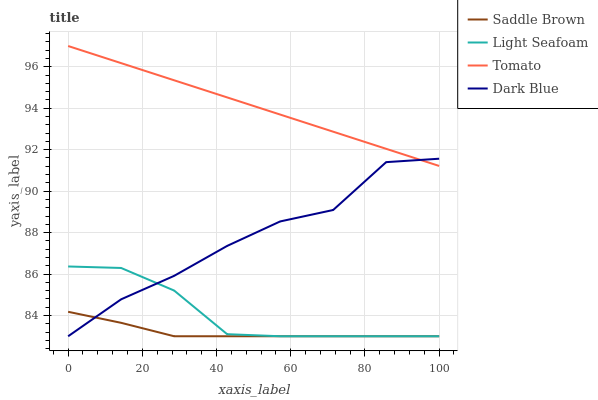Does Dark Blue have the minimum area under the curve?
Answer yes or no. No. Does Dark Blue have the maximum area under the curve?
Answer yes or no. No. Is Light Seafoam the smoothest?
Answer yes or no. No. Is Light Seafoam the roughest?
Answer yes or no. No. Does Dark Blue have the highest value?
Answer yes or no. No. Is Light Seafoam less than Tomato?
Answer yes or no. Yes. Is Tomato greater than Saddle Brown?
Answer yes or no. Yes. Does Light Seafoam intersect Tomato?
Answer yes or no. No. 